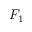<formula> <loc_0><loc_0><loc_500><loc_500>F _ { 1 }</formula> 